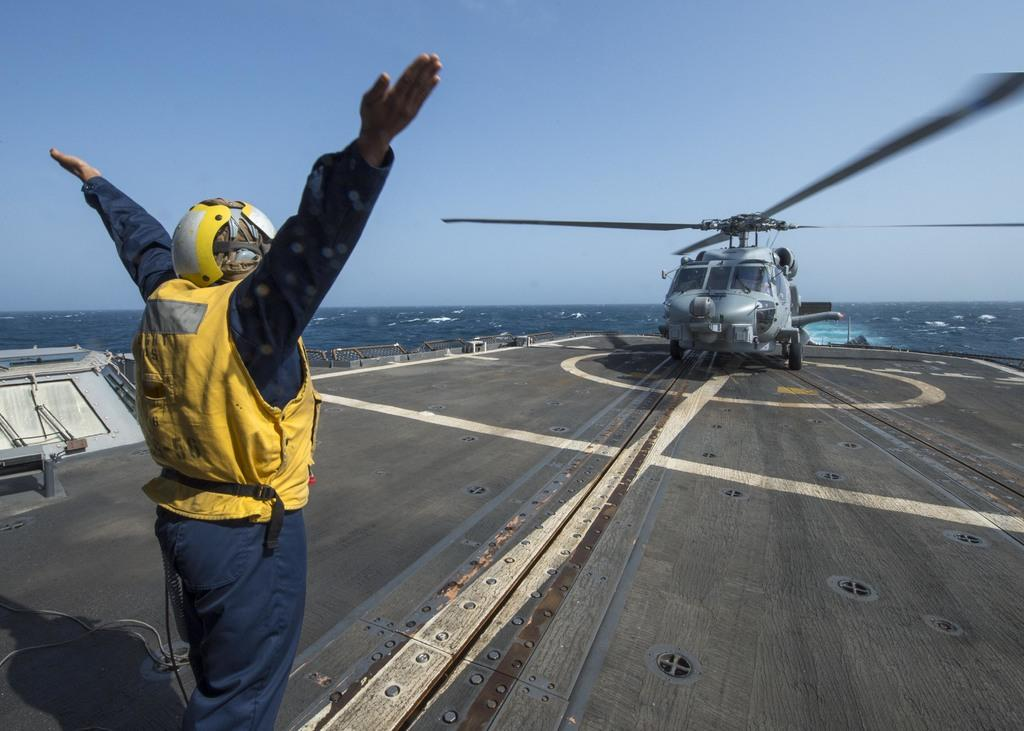What is the position of the man in the image? The man is standing in the image and facing backward. What is the man wearing in the image? The man is wearing clothes and a helmet. What is in front of the man in the image? There is a helicopter in front of the man. What natural elements can be seen in the image? The sea and the sky are visible in the image. What type of nerve is responsible for the man's ability to fly the helicopter in the image? There is no mention of the man flying the helicopter in the image, nor is there any information about his nerves. 